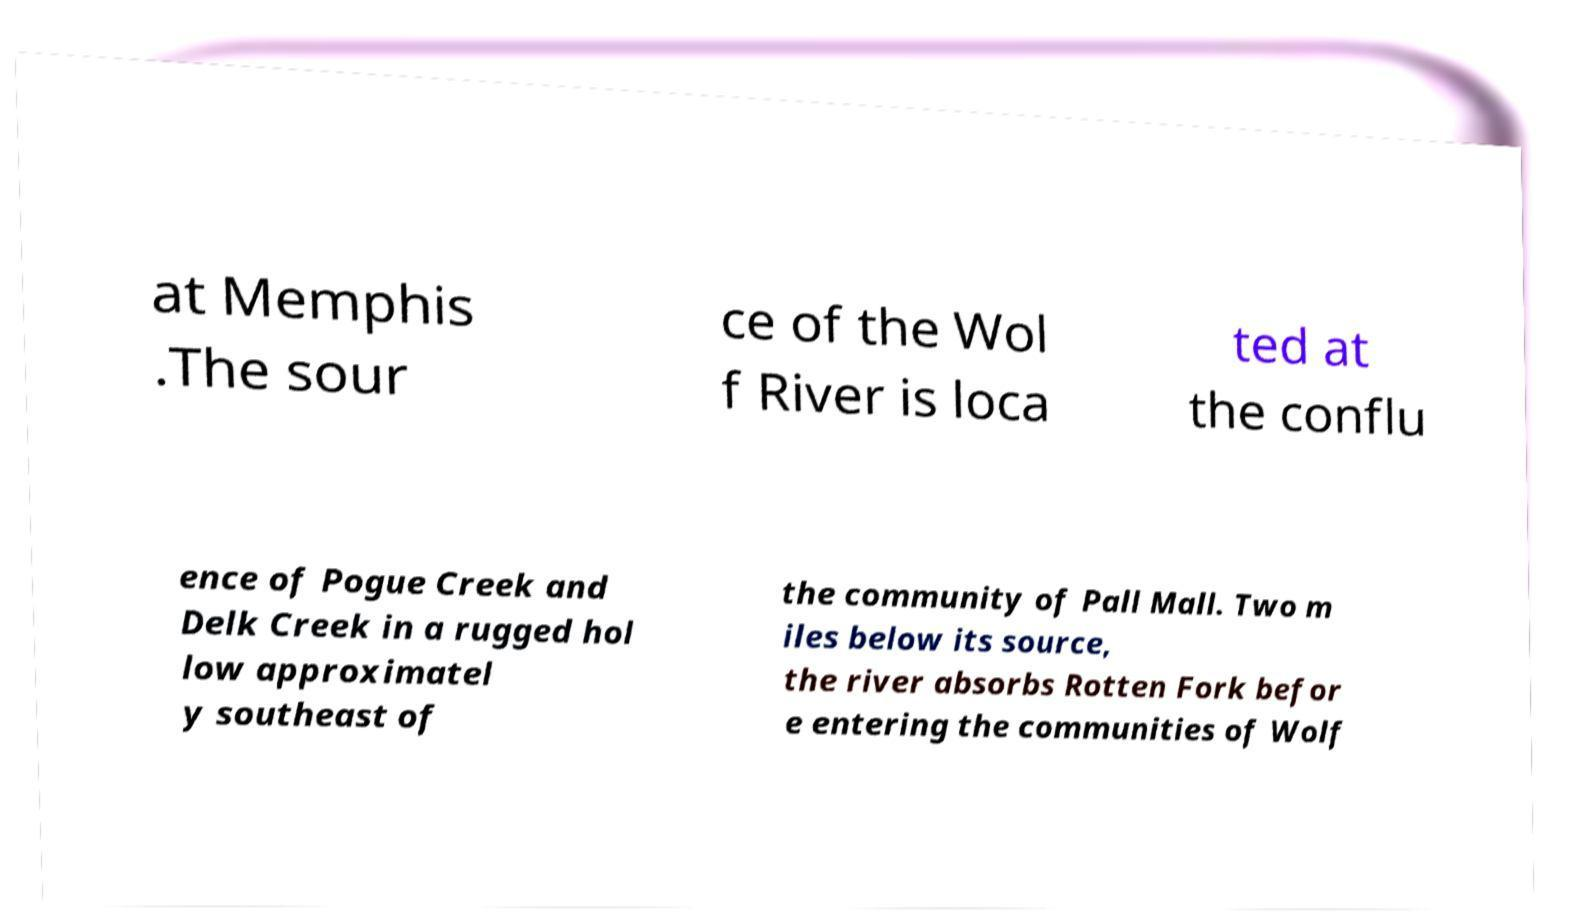There's text embedded in this image that I need extracted. Can you transcribe it verbatim? at Memphis .The sour ce of the Wol f River is loca ted at the conflu ence of Pogue Creek and Delk Creek in a rugged hol low approximatel y southeast of the community of Pall Mall. Two m iles below its source, the river absorbs Rotten Fork befor e entering the communities of Wolf 